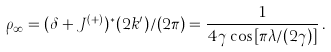<formula> <loc_0><loc_0><loc_500><loc_500>\rho _ { \infty } = ( \delta + J ^ { ( + ) } ) ^ { * } ( 2 k ^ { \prime } ) / ( 2 \pi ) = \frac { 1 } { 4 \gamma \cos [ \pi \lambda / ( 2 \gamma ) ] } \, .</formula> 